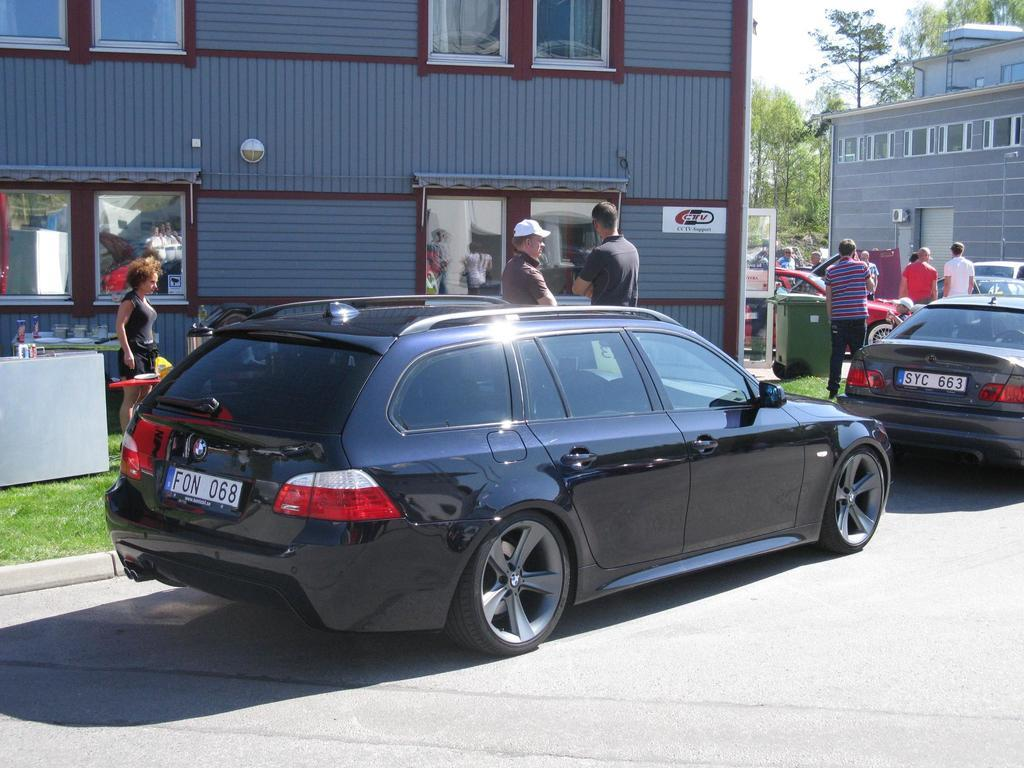<image>
Present a compact description of the photo's key features. A dark blue hatchback with license plate number F0N 068 parked by a curb 